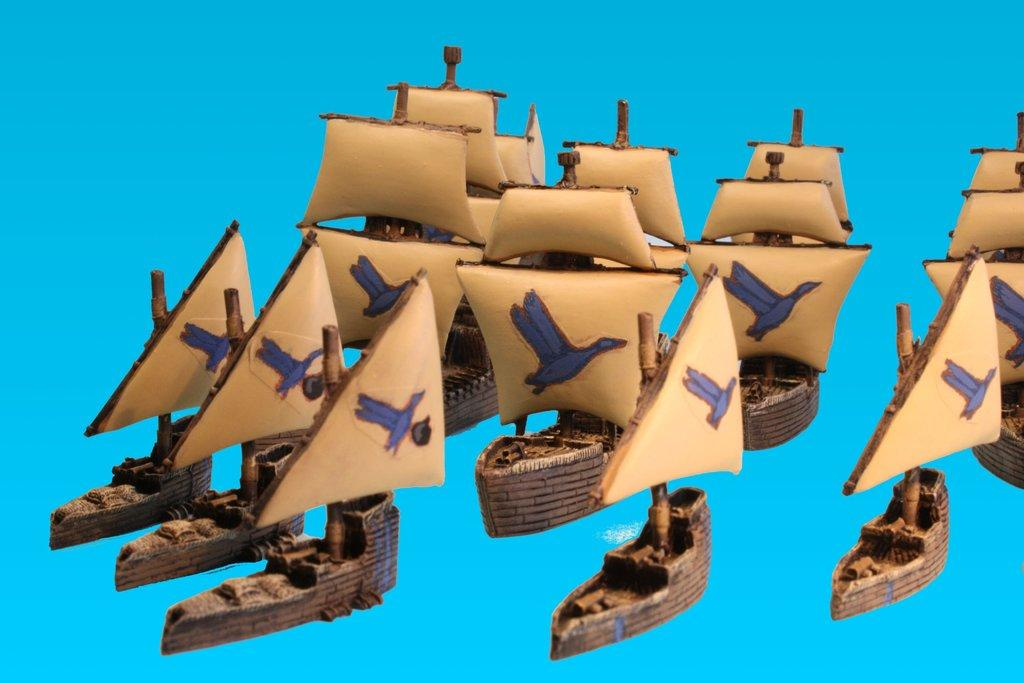What type of image is shown in the picture? The image contains a depiction picture. What color are the multiple objects in the depiction picture? There are multiple brown-colored things in the depiction picture. What color is the background of the depiction picture? The background of the depiction picture is blue. What type of apparel are the boys wearing in the depiction picture? There are no boys present in the depiction picture, so it is not possible to determine what type of apparel they might be wearing. 